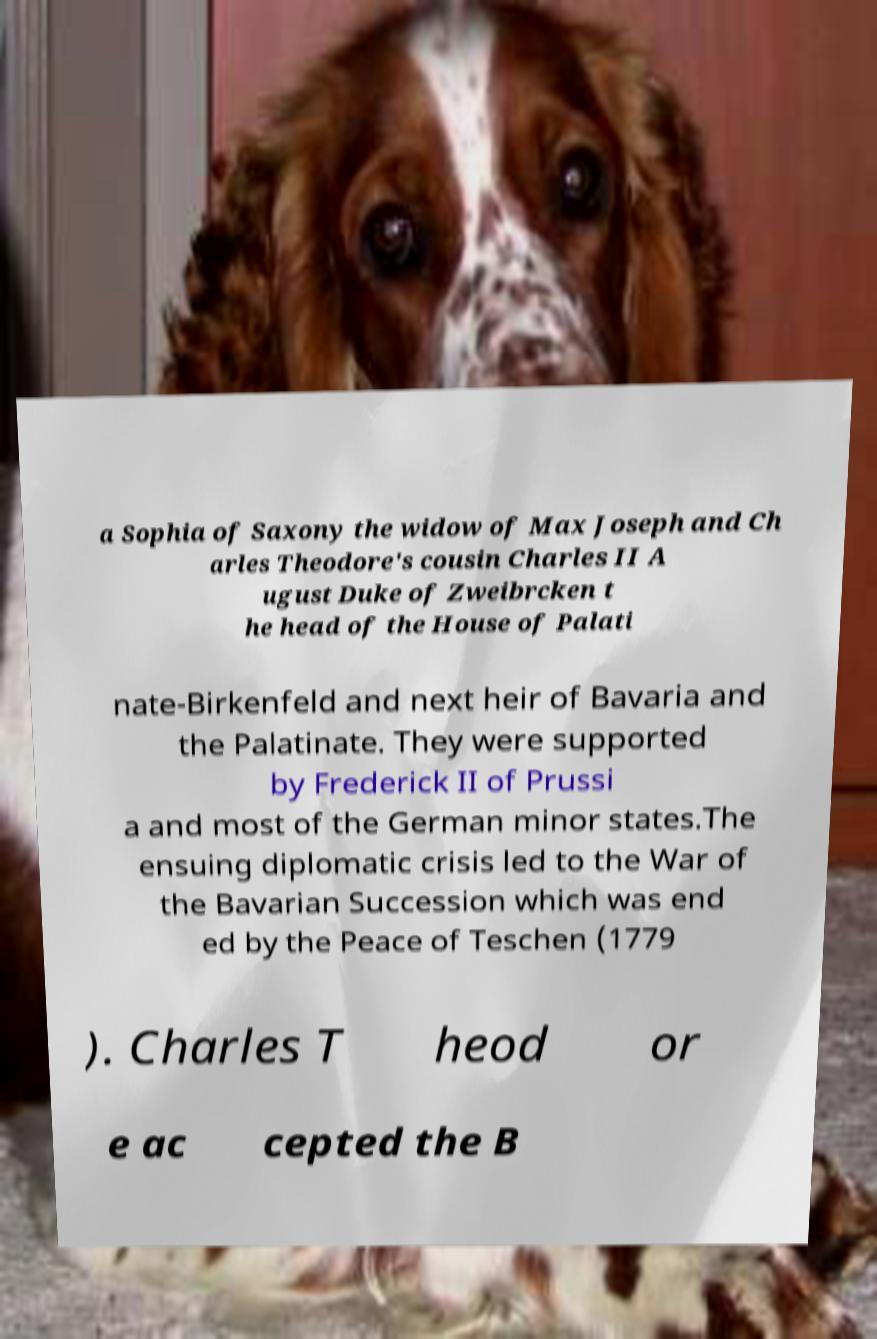There's text embedded in this image that I need extracted. Can you transcribe it verbatim? a Sophia of Saxony the widow of Max Joseph and Ch arles Theodore's cousin Charles II A ugust Duke of Zweibrcken t he head of the House of Palati nate-Birkenfeld and next heir of Bavaria and the Palatinate. They were supported by Frederick II of Prussi a and most of the German minor states.The ensuing diplomatic crisis led to the War of the Bavarian Succession which was end ed by the Peace of Teschen (1779 ). Charles T heod or e ac cepted the B 